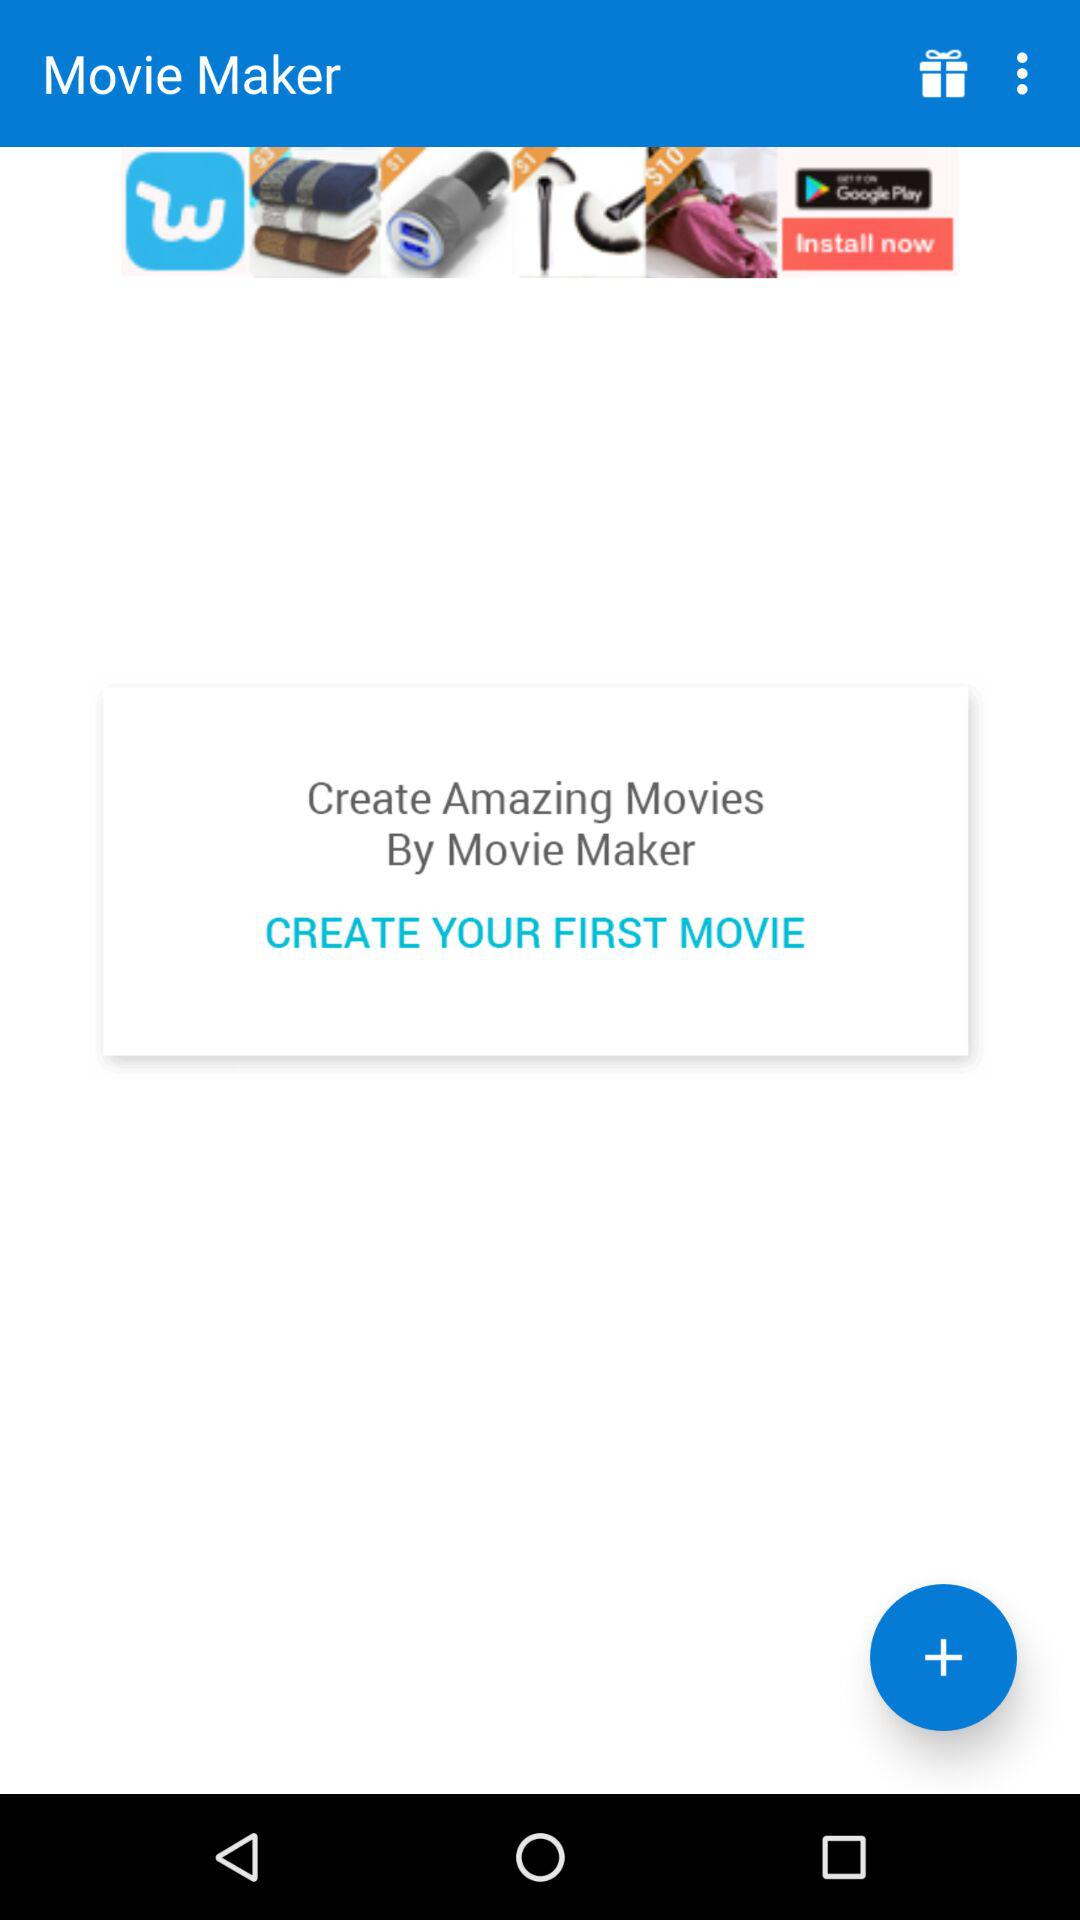What is the name of the application? The name of the application is "Movie Maker". 